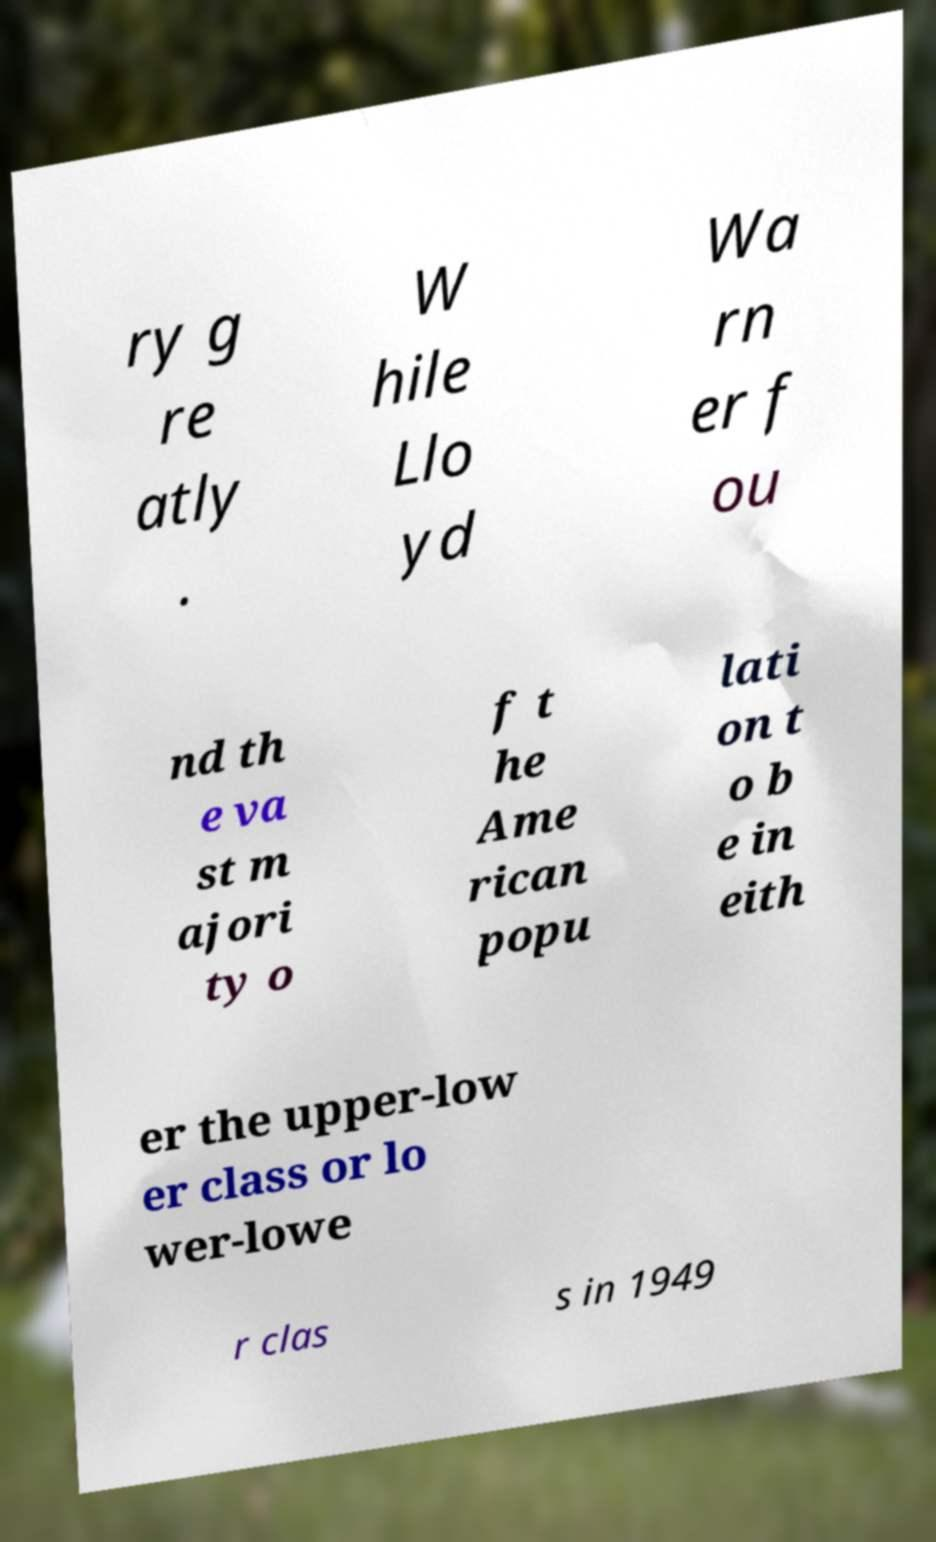Can you accurately transcribe the text from the provided image for me? ry g re atly . W hile Llo yd Wa rn er f ou nd th e va st m ajori ty o f t he Ame rican popu lati on t o b e in eith er the upper-low er class or lo wer-lowe r clas s in 1949 